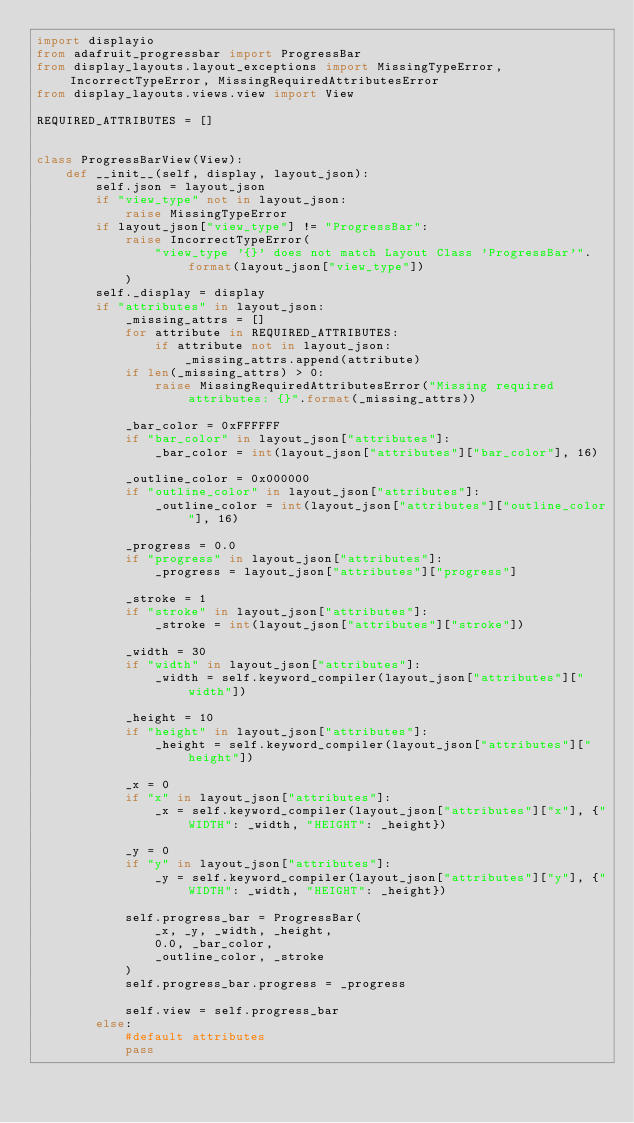<code> <loc_0><loc_0><loc_500><loc_500><_Python_>import displayio
from adafruit_progressbar import ProgressBar
from display_layouts.layout_exceptions import MissingTypeError, IncorrectTypeError, MissingRequiredAttributesError
from display_layouts.views.view import View

REQUIRED_ATTRIBUTES = []


class ProgressBarView(View):
    def __init__(self, display, layout_json):
        self.json = layout_json
        if "view_type" not in layout_json:
            raise MissingTypeError
        if layout_json["view_type"] != "ProgressBar":
            raise IncorrectTypeError(
                "view_type '{}' does not match Layout Class 'ProgressBar'".format(layout_json["view_type"])
            )
        self._display = display
        if "attributes" in layout_json:
            _missing_attrs = []
            for attribute in REQUIRED_ATTRIBUTES:
                if attribute not in layout_json:
                    _missing_attrs.append(attribute)
            if len(_missing_attrs) > 0:
                raise MissingRequiredAttributesError("Missing required attributes: {}".format(_missing_attrs))

            _bar_color = 0xFFFFFF
            if "bar_color" in layout_json["attributes"]:
                _bar_color = int(layout_json["attributes"]["bar_color"], 16)

            _outline_color = 0x000000
            if "outline_color" in layout_json["attributes"]:
                _outline_color = int(layout_json["attributes"]["outline_color"], 16)

            _progress = 0.0
            if "progress" in layout_json["attributes"]:
                _progress = layout_json["attributes"]["progress"]

            _stroke = 1
            if "stroke" in layout_json["attributes"]:
                _stroke = int(layout_json["attributes"]["stroke"])

            _width = 30
            if "width" in layout_json["attributes"]:
                _width = self.keyword_compiler(layout_json["attributes"]["width"])

            _height = 10
            if "height" in layout_json["attributes"]:
                _height = self.keyword_compiler(layout_json["attributes"]["height"])

            _x = 0
            if "x" in layout_json["attributes"]:
                _x = self.keyword_compiler(layout_json["attributes"]["x"], {"WIDTH": _width, "HEIGHT": _height})

            _y = 0
            if "y" in layout_json["attributes"]:
                _y = self.keyword_compiler(layout_json["attributes"]["y"], {"WIDTH": _width, "HEIGHT": _height})

            self.progress_bar = ProgressBar(
                _x, _y, _width, _height,
                0.0, _bar_color,
                _outline_color, _stroke
            )
            self.progress_bar.progress = _progress

            self.view = self.progress_bar
        else:
            #default attributes
            pass</code> 